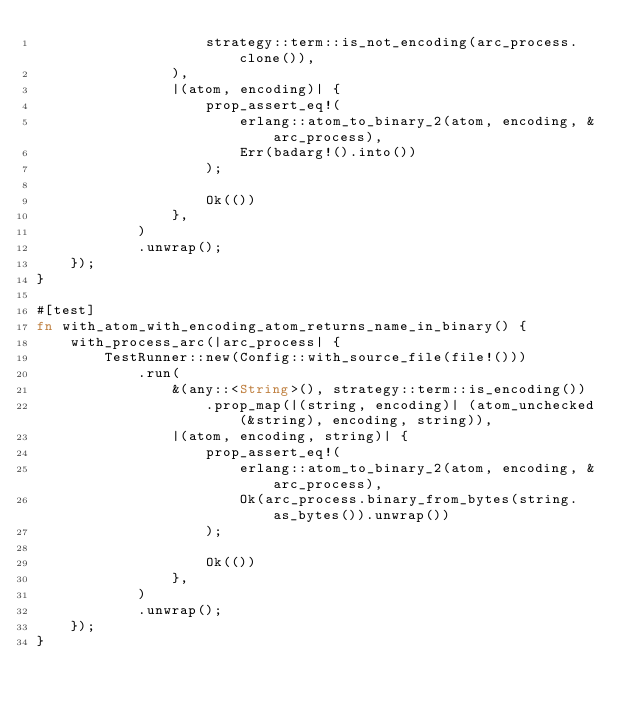<code> <loc_0><loc_0><loc_500><loc_500><_Rust_>                    strategy::term::is_not_encoding(arc_process.clone()),
                ),
                |(atom, encoding)| {
                    prop_assert_eq!(
                        erlang::atom_to_binary_2(atom, encoding, &arc_process),
                        Err(badarg!().into())
                    );

                    Ok(())
                },
            )
            .unwrap();
    });
}

#[test]
fn with_atom_with_encoding_atom_returns_name_in_binary() {
    with_process_arc(|arc_process| {
        TestRunner::new(Config::with_source_file(file!()))
            .run(
                &(any::<String>(), strategy::term::is_encoding())
                    .prop_map(|(string, encoding)| (atom_unchecked(&string), encoding, string)),
                |(atom, encoding, string)| {
                    prop_assert_eq!(
                        erlang::atom_to_binary_2(atom, encoding, &arc_process),
                        Ok(arc_process.binary_from_bytes(string.as_bytes()).unwrap())
                    );

                    Ok(())
                },
            )
            .unwrap();
    });
}
</code> 